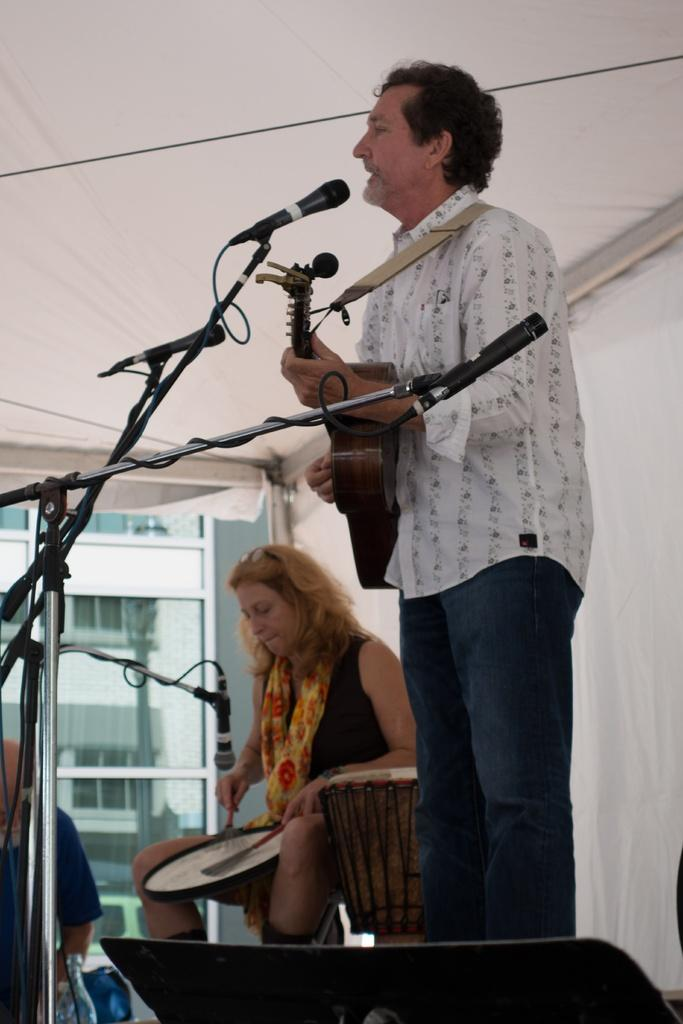What is the person in the image doing? The person is playing a guitar. What is the person wearing in the image? The person is wearing a white shirt. What object is in front of the person? There is a microphone in front of the person. What is the woman in the background of the image doing? The woman is beating drums. How many birds are in the flock that is flying by the side of the person in the image? There are no birds or flocks present in the image. 